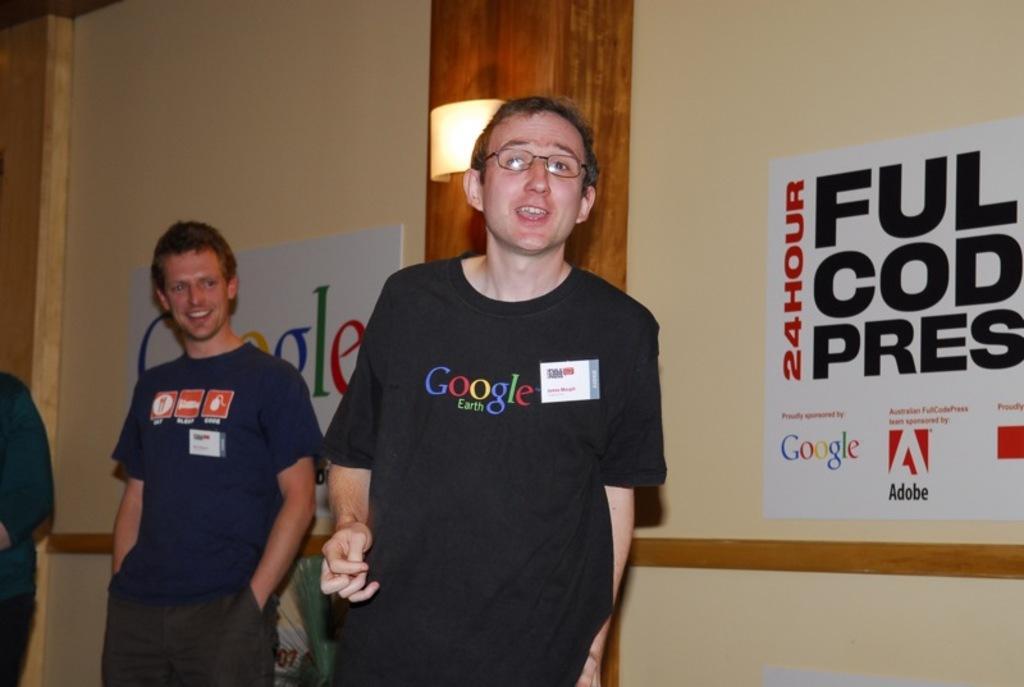Describe this image in one or two sentences. In this image we can see three persons, in the background there is a wall with posters and a pillar with light. 